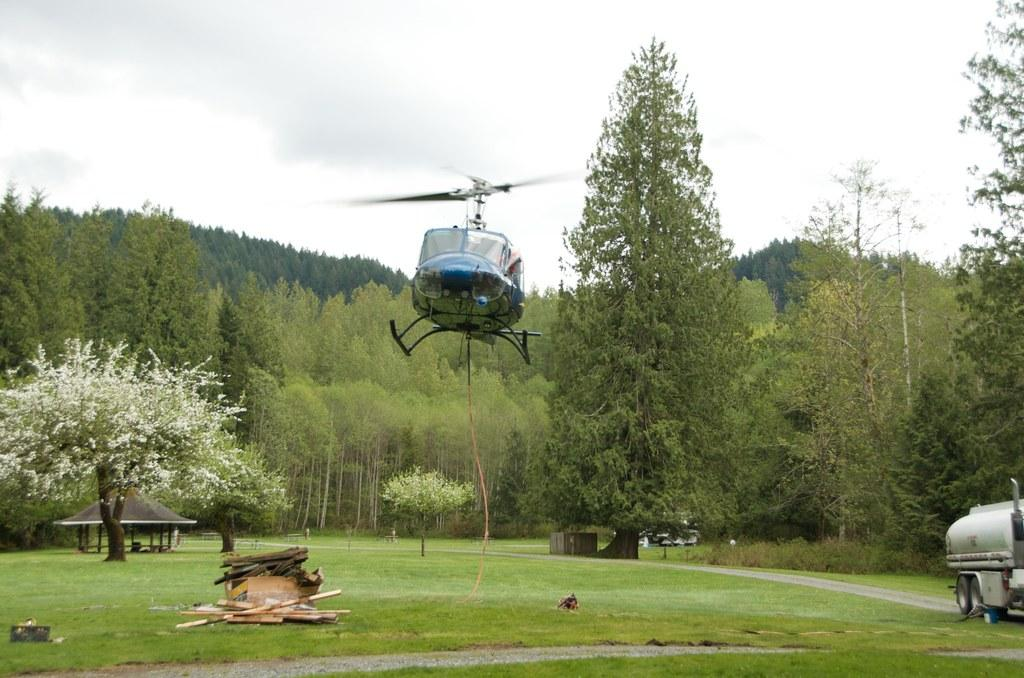What is the main subject of the image? There is an aircraft in the image. Can you describe the color of the aircraft? The aircraft is blue. What can be seen in the background of the image? There are trees and the sky visible in the background of the image. What is the color of the trees? The trees are green. What is the color of the sky in the image? The sky is white. Where is the hook located in the image? There is no hook present in the image. Can you describe the volleyball game happening in the background of the image? There is no volleyball game present in the image; it features an aircraft, trees, and a white sky. 